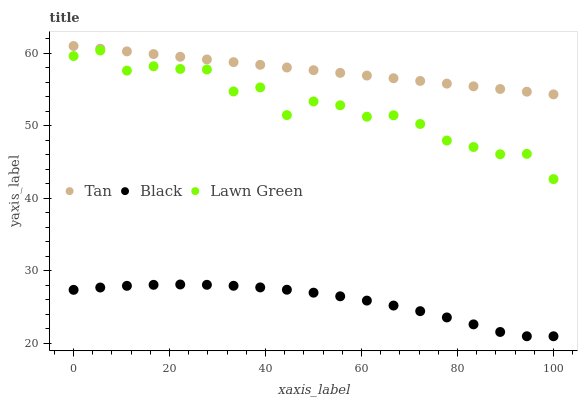Does Black have the minimum area under the curve?
Answer yes or no. Yes. Does Tan have the maximum area under the curve?
Answer yes or no. Yes. Does Tan have the minimum area under the curve?
Answer yes or no. No. Does Black have the maximum area under the curve?
Answer yes or no. No. Is Tan the smoothest?
Answer yes or no. Yes. Is Lawn Green the roughest?
Answer yes or no. Yes. Is Black the smoothest?
Answer yes or no. No. Is Black the roughest?
Answer yes or no. No. Does Black have the lowest value?
Answer yes or no. Yes. Does Tan have the lowest value?
Answer yes or no. No. Does Tan have the highest value?
Answer yes or no. Yes. Does Black have the highest value?
Answer yes or no. No. Is Black less than Tan?
Answer yes or no. Yes. Is Tan greater than Black?
Answer yes or no. Yes. Does Black intersect Tan?
Answer yes or no. No. 